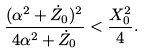<formula> <loc_0><loc_0><loc_500><loc_500>\frac { ( \alpha ^ { 2 } + \dot { Z } _ { 0 } ) ^ { 2 } } { 4 \alpha ^ { 2 } + \dot { Z } _ { 0 } } < \frac { X _ { 0 } ^ { 2 } } { 4 } .</formula> 